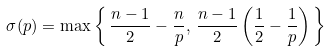Convert formula to latex. <formula><loc_0><loc_0><loc_500><loc_500>\sigma ( p ) = \max \left \{ \, \frac { n - 1 } 2 - \frac { n } p , \, \frac { n - 1 } 2 \left ( \frac { 1 } { 2 } - \frac { 1 } { p } \right ) \, \right \}</formula> 